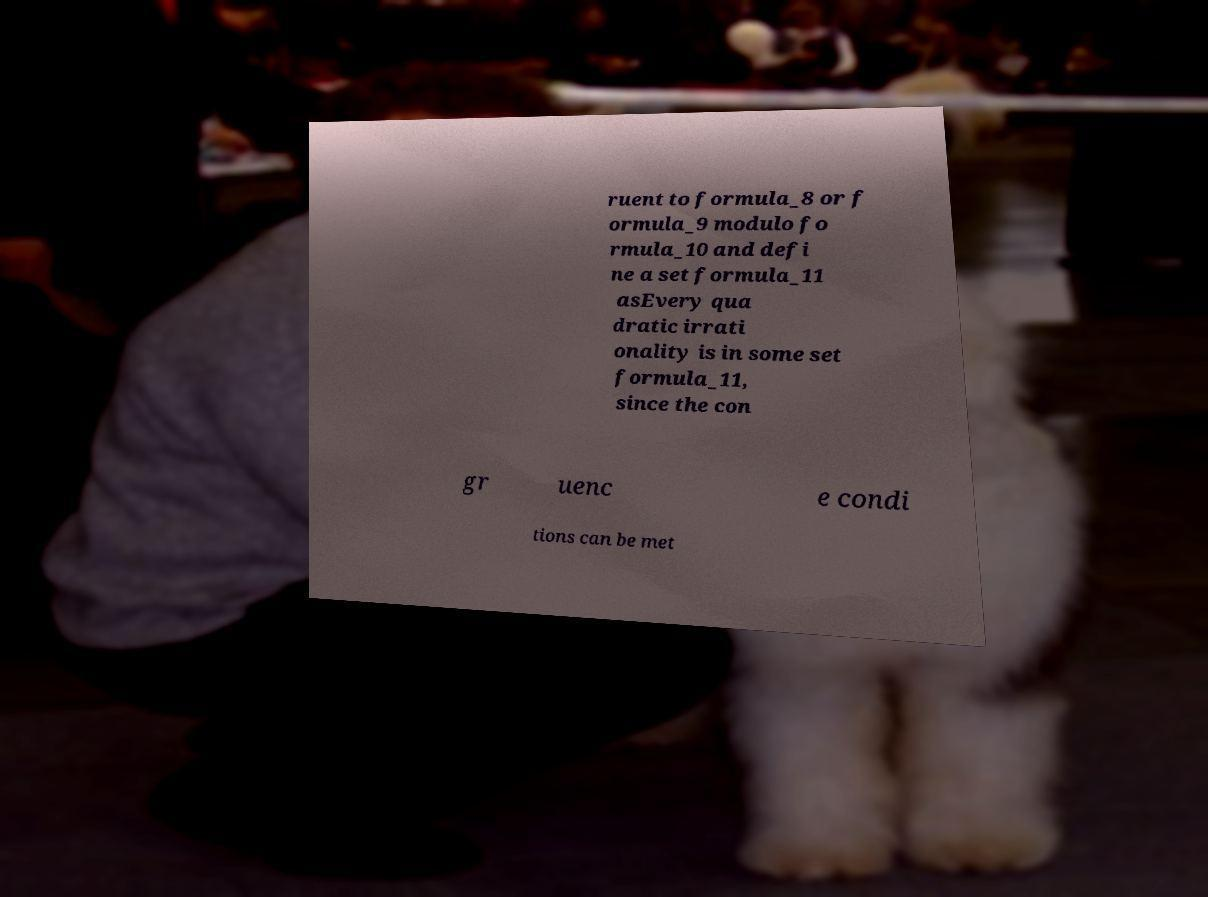I need the written content from this picture converted into text. Can you do that? ruent to formula_8 or f ormula_9 modulo fo rmula_10 and defi ne a set formula_11 asEvery qua dratic irrati onality is in some set formula_11, since the con gr uenc e condi tions can be met 